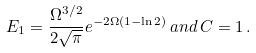Convert formula to latex. <formula><loc_0><loc_0><loc_500><loc_500>E _ { 1 } = \frac { \Omega ^ { 3 / 2 } } { 2 \sqrt { \pi } } e ^ { - 2 \Omega ( 1 - \ln 2 ) } \, a n d \, C = 1 \, .</formula> 